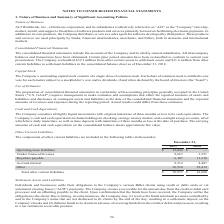According to Aci Worldwide's financial document, What were the operating lease liabilities in 2019? According to the financial document, $15,049 (in thousands). The relevant text states: "Operating lease liabilities $ 15,049 $ —..." Also, What were the royalties payable in 2019? According to the financial document, 6,107 (in thousands). The relevant text states: "Royalties payable 6,107 11,318..." Also, What were the royalties payable in 2018? According to the financial document, 11,318 (in thousands). The relevant text states: "Royalties payable 6,107 11,318..." Also, can you calculate: What was the change in vendor financed licenses between 2018 and 2019? Based on the calculation: 9,667-3,551, the result is 6116 (in thousands). This is based on the information: "Vendor financed licenses 9,667 3,551 Vendor financed licenses 9,667 3,551..." The key data points involved are: 3,551, 9,667. Also, can you calculate: What was the change in accrued interest between 2018 and 2019? Based on the calculation: 9,212-8,407, the result is 805 (in thousands). This is based on the information: "Accrued interest 9,212 8,407 Accrued interest 9,212 8,407..." The key data points involved are: 8,407, 9,212. Also, can you calculate: What was the percentage change in total other current liabilities between 2018 and 2019? To answer this question, I need to perform calculations using the financial data. The calculation is: ($76,971-$61,688)/$61,688, which equals 24.77 (percentage). This is based on the information: "Total other current liabilities $ 76,971 $ 61,688 Total other current liabilities $ 76,971 $ 61,688..." The key data points involved are: 61,688, 76,971. 